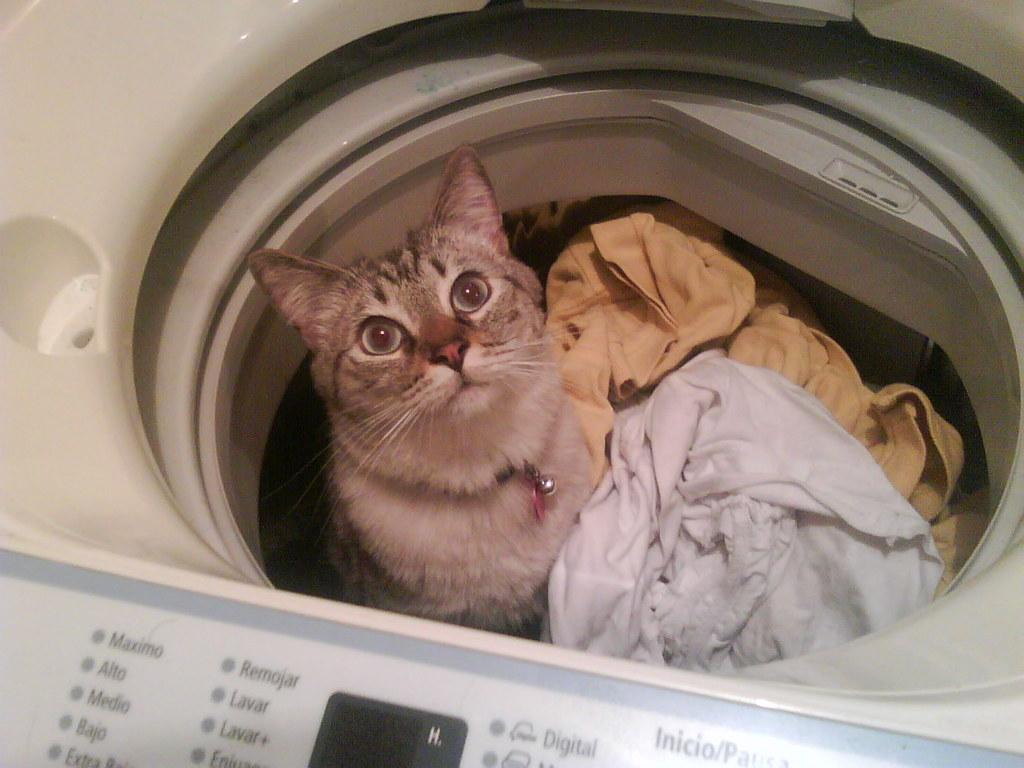What appliance can be seen in the image? There is a washing machine in the image. What is inside the washing machine? A cat is present in the washing machine, along with clothes. What is the purpose of the washing machine? The washing machine is used for cleaning clothes, as indicated by the presence of clothes inside. Is there any text or labeling on the washing machine? Yes, there is text on the washing machine. What type of polish is being applied to the cloud in the image? There is no cloud or polish present in the image; it features a washing machine with a cat and clothes inside. 